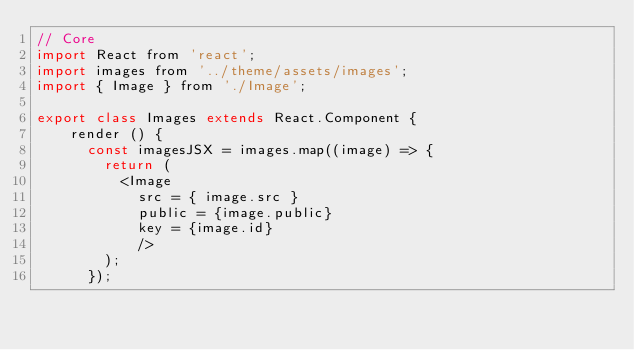Convert code to text. <code><loc_0><loc_0><loc_500><loc_500><_JavaScript_>// Core
import React from 'react';
import images from '../theme/assets/images';
import { Image } from './Image';

export class Images extends React.Component {
    render () {
    	const imagesJSX = images.map((image) => {
    		return (
    			<Image 
    				src = { image.src } 
    				public = {image.public}
    				key = {image.id}
    				/>
    		);
    	});</code> 